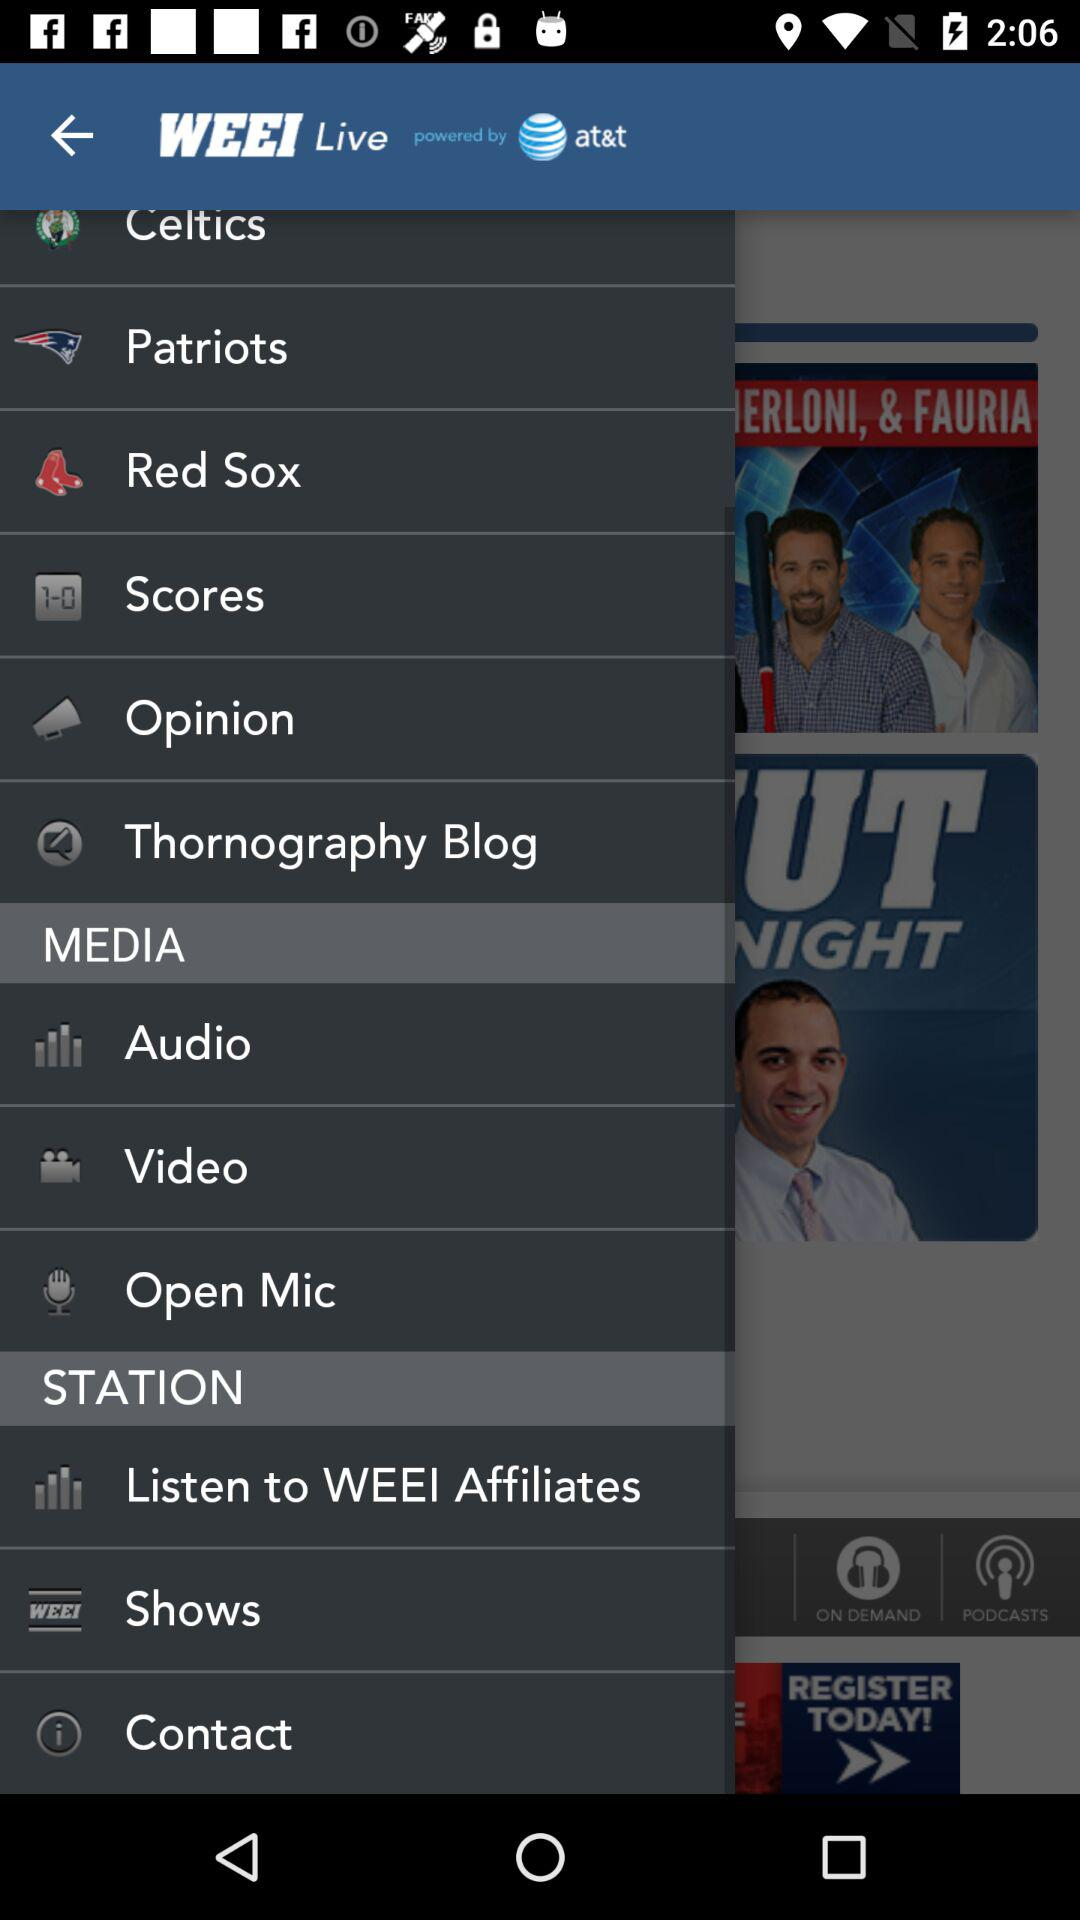How many items are in the 'Media' section that have a text label?
Answer the question using a single word or phrase. 3 